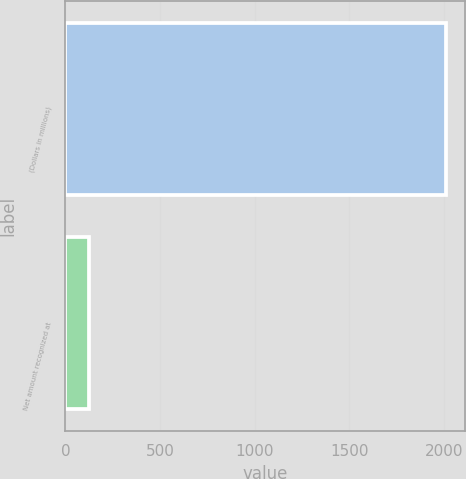<chart> <loc_0><loc_0><loc_500><loc_500><bar_chart><fcel>(Dollars in millions)<fcel>Net amount recognized at<nl><fcel>2014<fcel>124<nl></chart> 